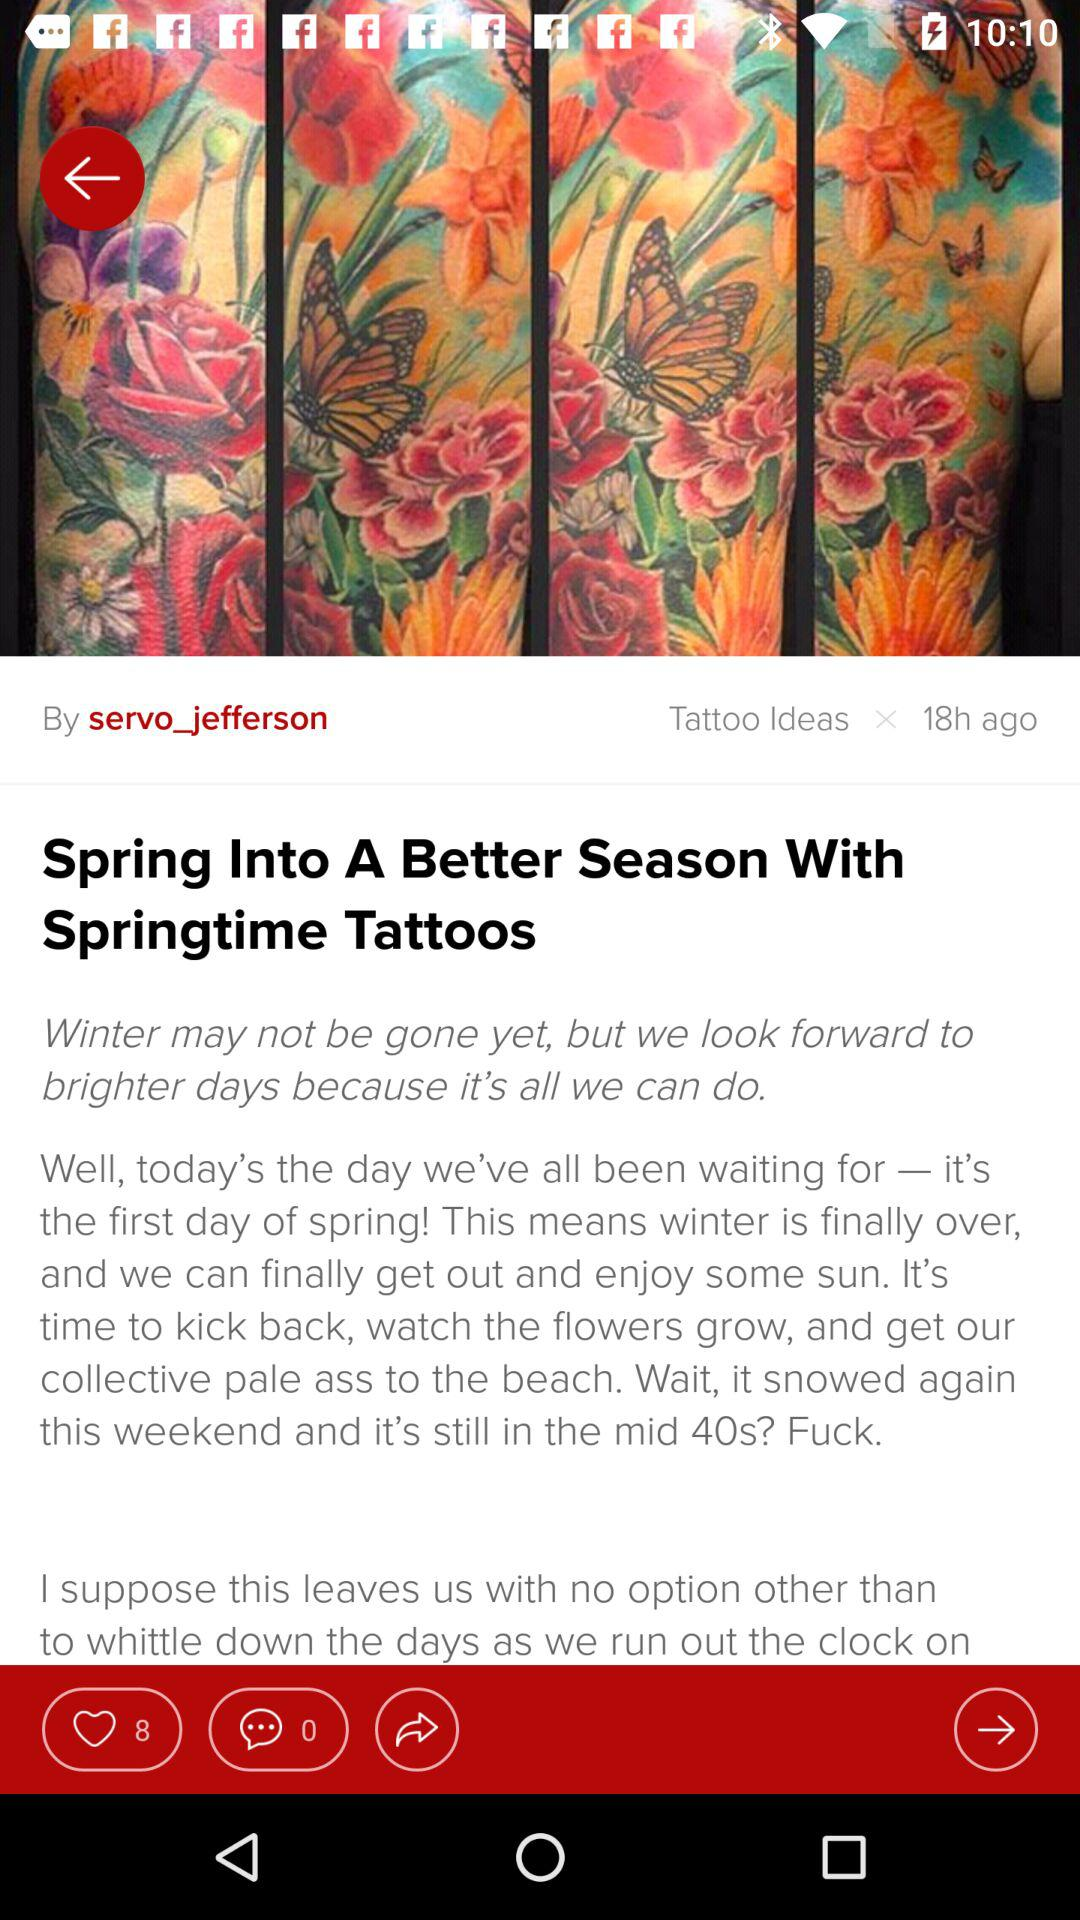How many times more likes than comments does the post have?
Answer the question using a single word or phrase. 8 